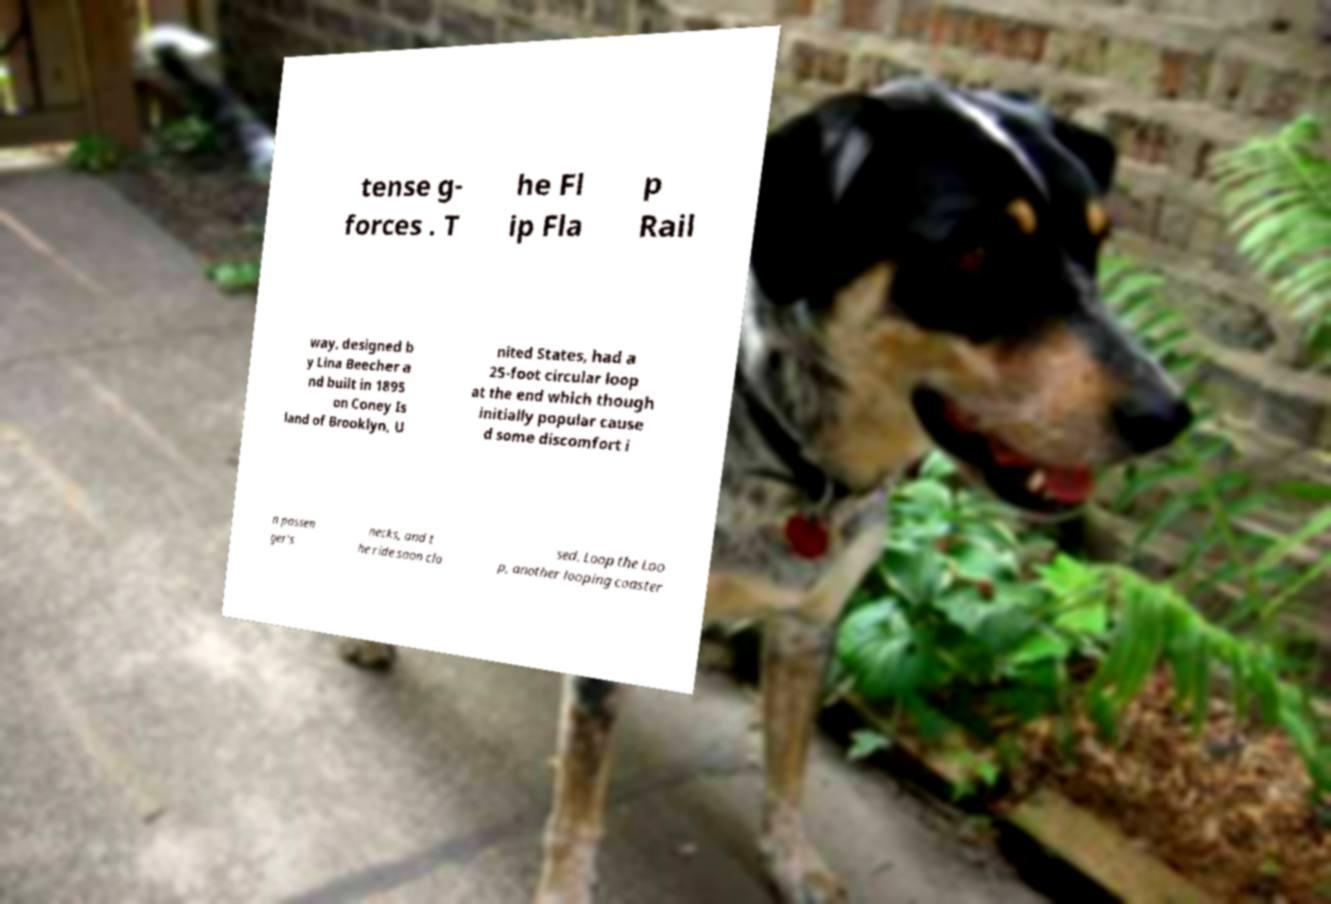Could you extract and type out the text from this image? tense g- forces . T he Fl ip Fla p Rail way, designed b y Lina Beecher a nd built in 1895 on Coney Is land of Brooklyn, U nited States, had a 25-foot circular loop at the end which though initially popular cause d some discomfort i n passen ger's necks, and t he ride soon clo sed. Loop the Loo p, another looping coaster 